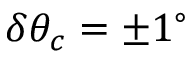Convert formula to latex. <formula><loc_0><loc_0><loc_500><loc_500>\delta \theta _ { c } = \pm 1 ^ { \circ }</formula> 